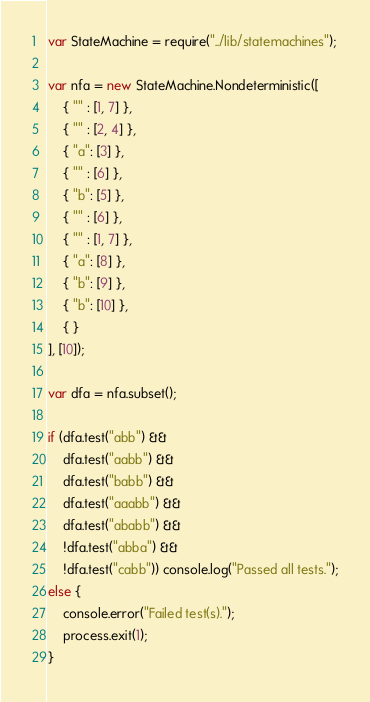<code> <loc_0><loc_0><loc_500><loc_500><_JavaScript_>var StateMachine = require("../lib/statemachines");

var nfa = new StateMachine.Nondeterministic([
    { "" : [1, 7] },
    { "" : [2, 4] },
    { "a": [3] },
    { "" : [6] },
    { "b": [5] },
    { "" : [6] },
    { "" : [1, 7] },
    { "a": [8] },
    { "b": [9] },
    { "b": [10] },
    { }
], [10]);

var dfa = nfa.subset();

if (dfa.test("abb") &&
    dfa.test("aabb") &&
    dfa.test("babb") &&
    dfa.test("aaabb") &&
    dfa.test("ababb") &&
    !dfa.test("abba") &&
    !dfa.test("cabb")) console.log("Passed all tests.");
else {
    console.error("Failed test(s).");
    process.exit(1);
}
</code> 